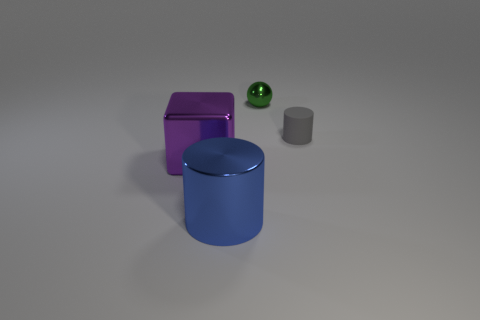Are there any blue cylinders that are behind the big thing that is left of the large shiny thing that is in front of the metal cube?
Your answer should be compact. No. How many purple objects have the same size as the green thing?
Offer a very short reply. 0. There is a block that is in front of the green shiny thing; does it have the same size as the cylinder that is in front of the purple shiny object?
Keep it short and to the point. Yes. There is a shiny thing that is in front of the green metallic sphere and behind the blue shiny thing; what shape is it?
Ensure brevity in your answer.  Cube. Are there any big metal objects that have the same color as the matte cylinder?
Give a very brief answer. No. Are any metal cubes visible?
Offer a terse response. Yes. There is a tiny object that is right of the tiny ball; what color is it?
Give a very brief answer. Gray. Does the block have the same size as the cylinder behind the big purple thing?
Offer a very short reply. No. There is a metallic thing that is in front of the rubber cylinder and right of the purple object; what size is it?
Ensure brevity in your answer.  Large. Are there any green balls that have the same material as the purple object?
Your answer should be very brief. Yes. 